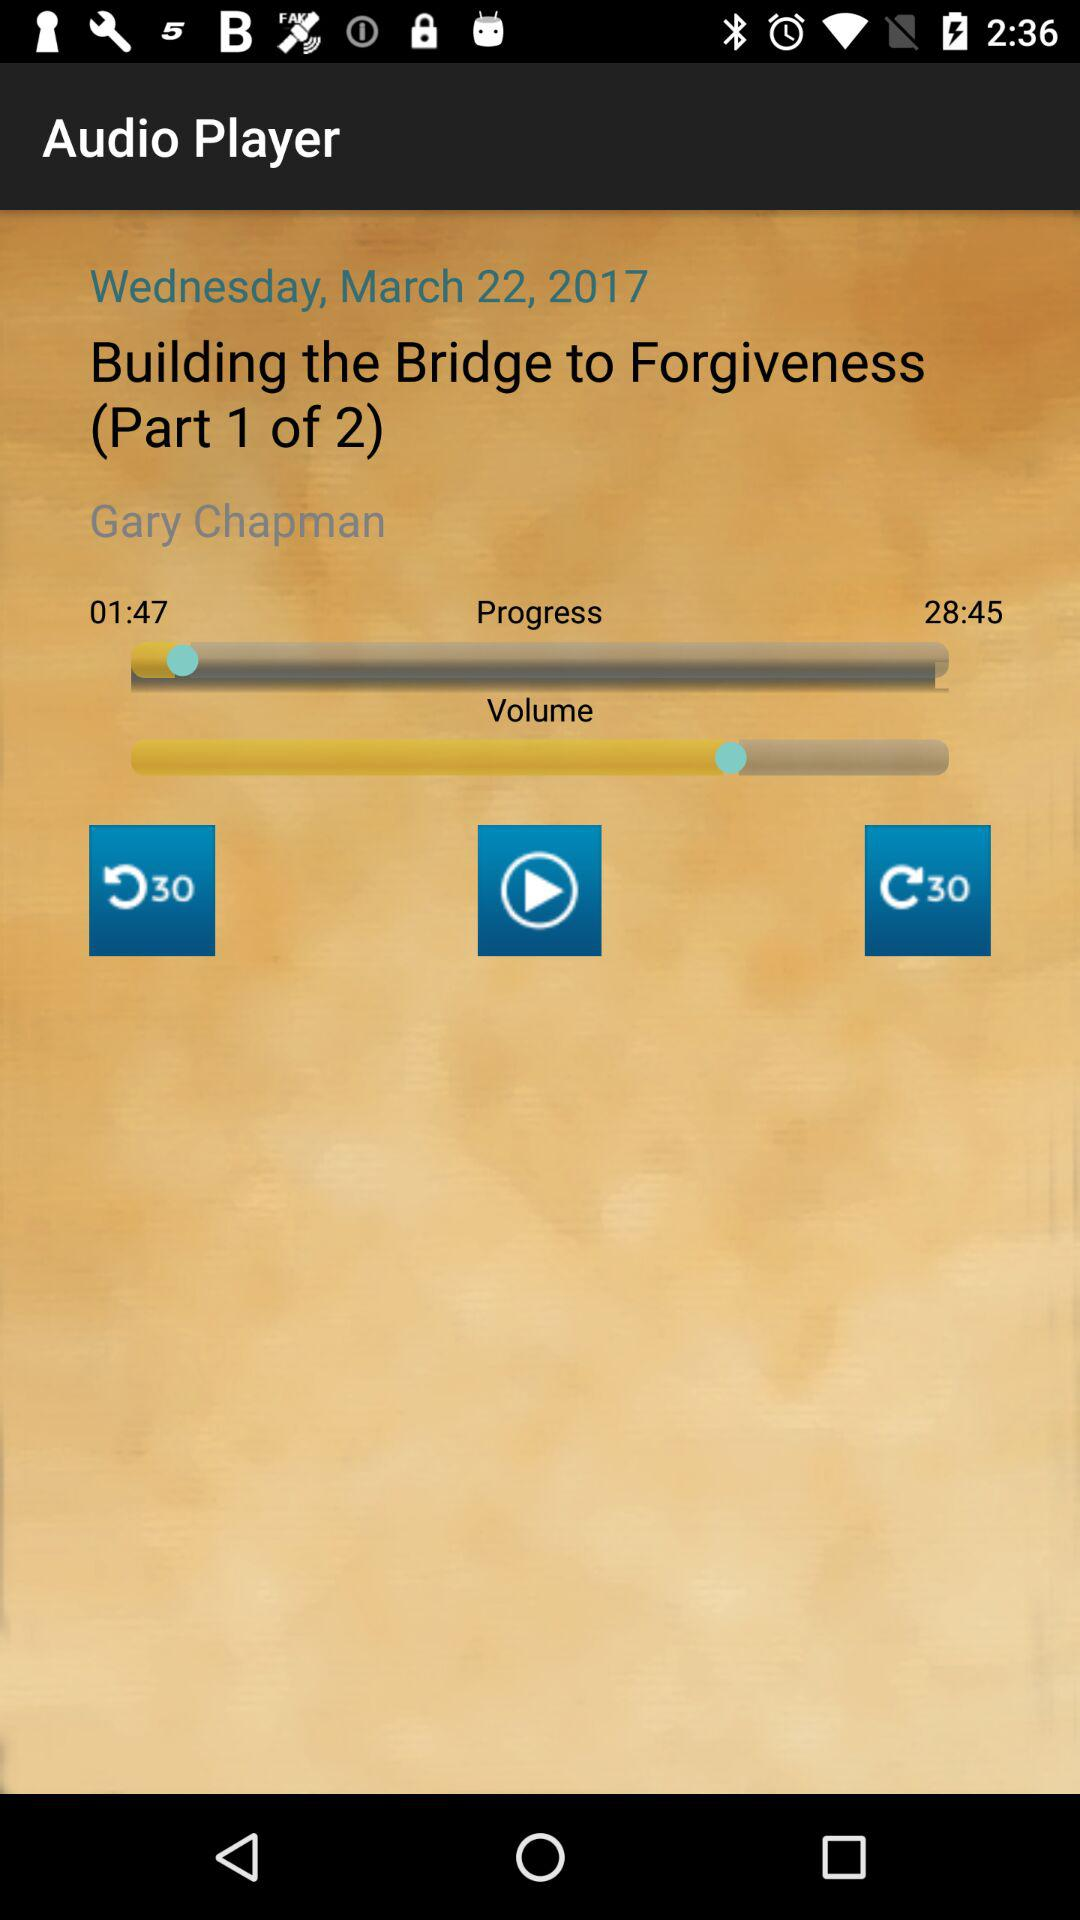What's the duration of the audio? The duration of the audio is 28:45. 